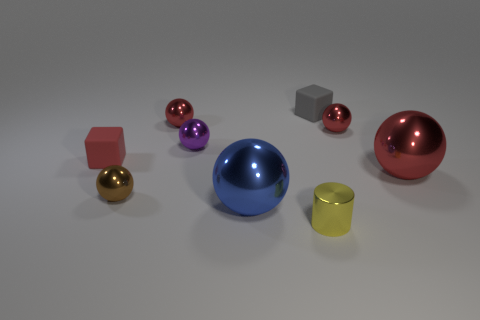Add 1 big red metal things. How many objects exist? 10 Subtract all small brown balls. How many balls are left? 5 Subtract all blue spheres. How many spheres are left? 5 Subtract all cylinders. How many objects are left? 8 Subtract 1 cylinders. How many cylinders are left? 0 Subtract all gray blocks. Subtract all purple balls. How many blocks are left? 1 Subtract all green cylinders. How many red balls are left? 3 Subtract all large red shiny balls. Subtract all large green things. How many objects are left? 8 Add 4 red things. How many red things are left? 8 Add 8 yellow metallic things. How many yellow metallic things exist? 9 